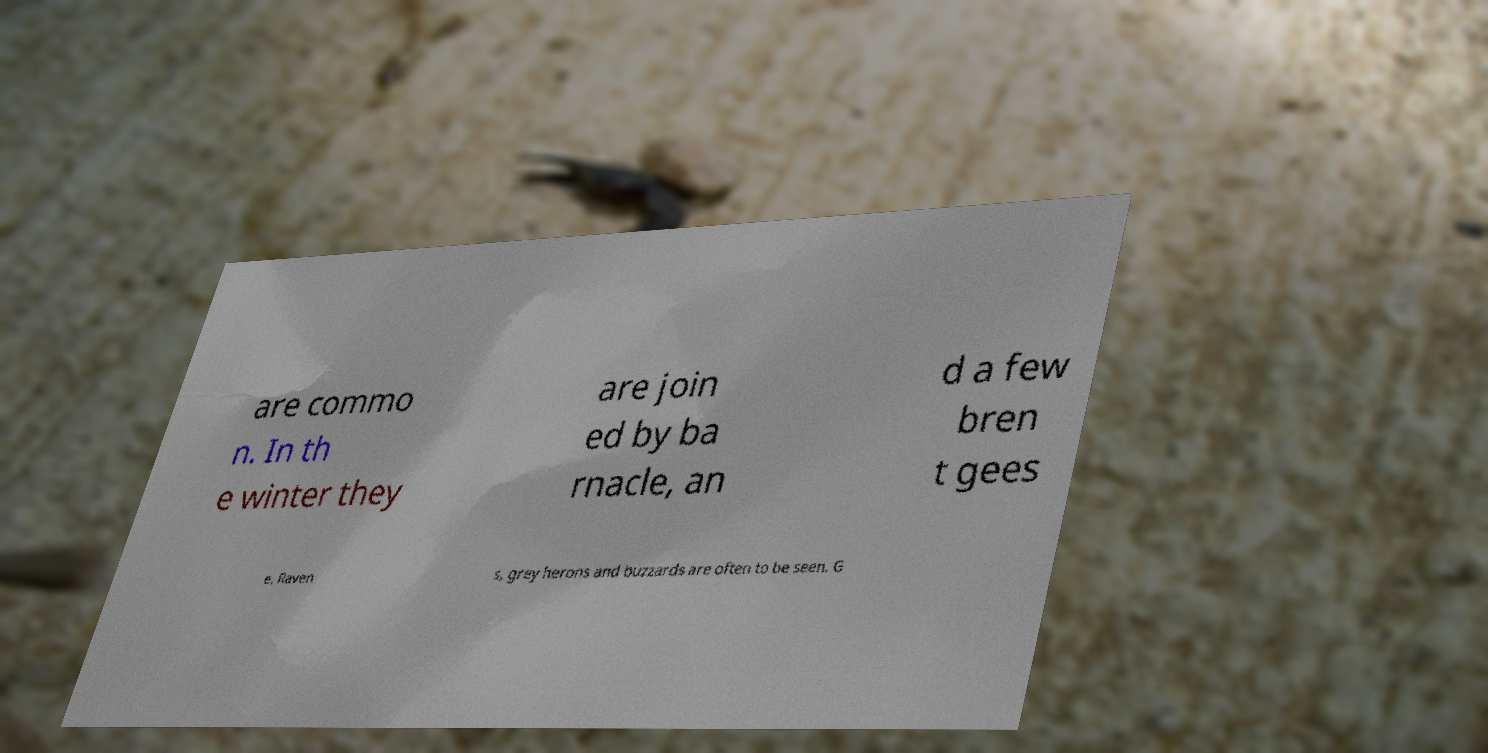What messages or text are displayed in this image? I need them in a readable, typed format. are commo n. In th e winter they are join ed by ba rnacle, an d a few bren t gees e. Raven s, grey herons and buzzards are often to be seen. G 